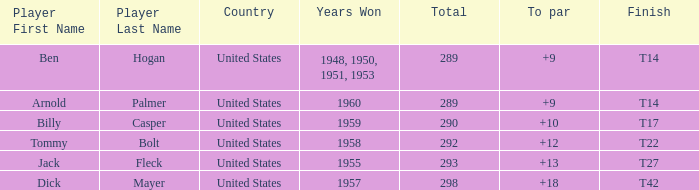What is the total number of Total, when To Par is 12? 1.0. 